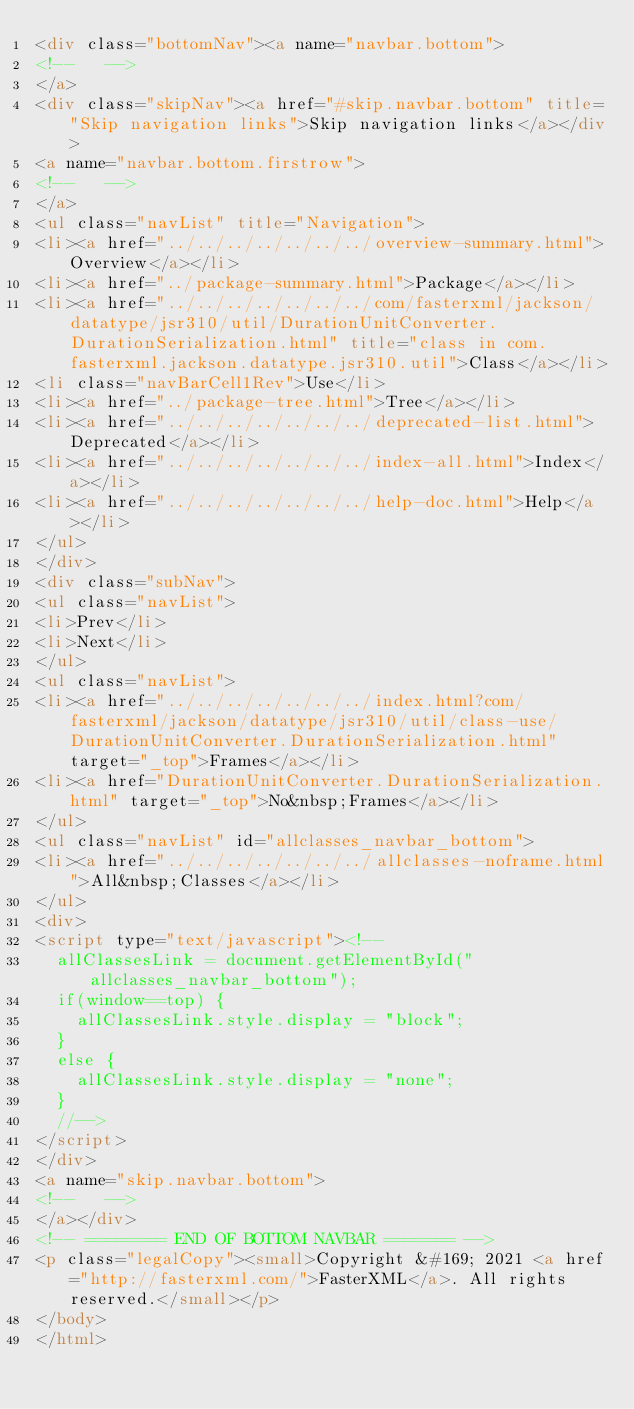<code> <loc_0><loc_0><loc_500><loc_500><_HTML_><div class="bottomNav"><a name="navbar.bottom">
<!--   -->
</a>
<div class="skipNav"><a href="#skip.navbar.bottom" title="Skip navigation links">Skip navigation links</a></div>
<a name="navbar.bottom.firstrow">
<!--   -->
</a>
<ul class="navList" title="Navigation">
<li><a href="../../../../../../../overview-summary.html">Overview</a></li>
<li><a href="../package-summary.html">Package</a></li>
<li><a href="../../../../../../../com/fasterxml/jackson/datatype/jsr310/util/DurationUnitConverter.DurationSerialization.html" title="class in com.fasterxml.jackson.datatype.jsr310.util">Class</a></li>
<li class="navBarCell1Rev">Use</li>
<li><a href="../package-tree.html">Tree</a></li>
<li><a href="../../../../../../../deprecated-list.html">Deprecated</a></li>
<li><a href="../../../../../../../index-all.html">Index</a></li>
<li><a href="../../../../../../../help-doc.html">Help</a></li>
</ul>
</div>
<div class="subNav">
<ul class="navList">
<li>Prev</li>
<li>Next</li>
</ul>
<ul class="navList">
<li><a href="../../../../../../../index.html?com/fasterxml/jackson/datatype/jsr310/util/class-use/DurationUnitConverter.DurationSerialization.html" target="_top">Frames</a></li>
<li><a href="DurationUnitConverter.DurationSerialization.html" target="_top">No&nbsp;Frames</a></li>
</ul>
<ul class="navList" id="allclasses_navbar_bottom">
<li><a href="../../../../../../../allclasses-noframe.html">All&nbsp;Classes</a></li>
</ul>
<div>
<script type="text/javascript"><!--
  allClassesLink = document.getElementById("allclasses_navbar_bottom");
  if(window==top) {
    allClassesLink.style.display = "block";
  }
  else {
    allClassesLink.style.display = "none";
  }
  //-->
</script>
</div>
<a name="skip.navbar.bottom">
<!--   -->
</a></div>
<!-- ======== END OF BOTTOM NAVBAR ======= -->
<p class="legalCopy"><small>Copyright &#169; 2021 <a href="http://fasterxml.com/">FasterXML</a>. All rights reserved.</small></p>
</body>
</html>
</code> 